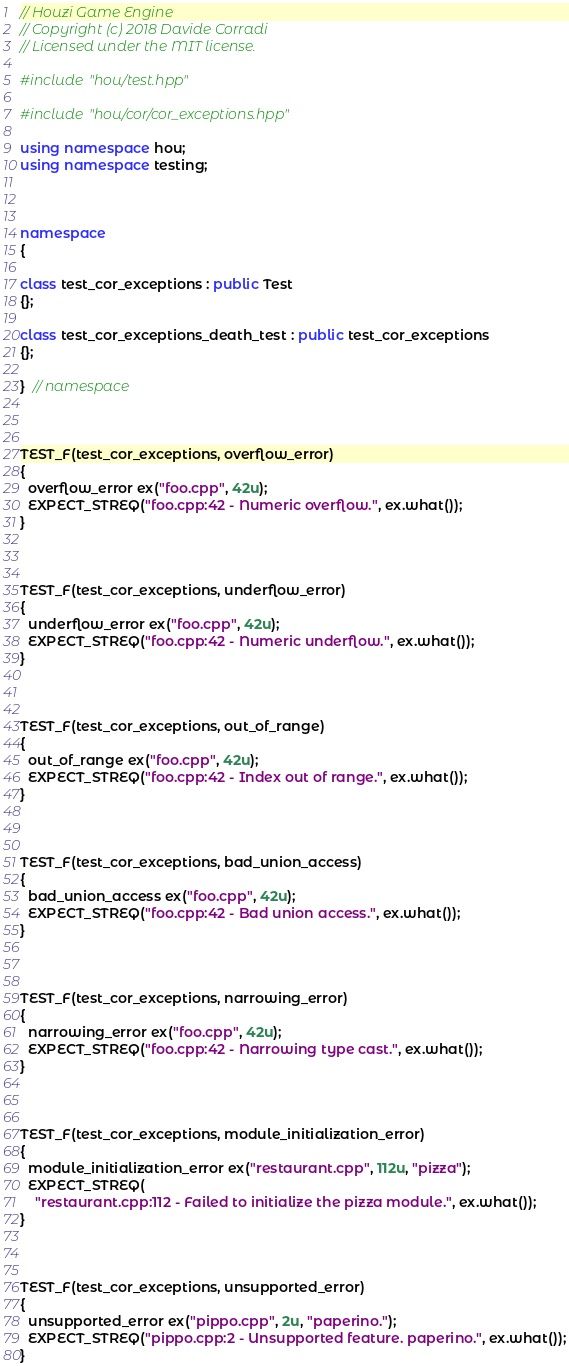<code> <loc_0><loc_0><loc_500><loc_500><_C++_>// Houzi Game Engine
// Copyright (c) 2018 Davide Corradi
// Licensed under the MIT license.

#include "hou/test.hpp"

#include "hou/cor/cor_exceptions.hpp"

using namespace hou;
using namespace testing;



namespace
{

class test_cor_exceptions : public Test
{};

class test_cor_exceptions_death_test : public test_cor_exceptions
{};

}  // namespace



TEST_F(test_cor_exceptions, overflow_error)
{
  overflow_error ex("foo.cpp", 42u);
  EXPECT_STREQ("foo.cpp:42 - Numeric overflow.", ex.what());
}



TEST_F(test_cor_exceptions, underflow_error)
{
  underflow_error ex("foo.cpp", 42u);
  EXPECT_STREQ("foo.cpp:42 - Numeric underflow.", ex.what());
}



TEST_F(test_cor_exceptions, out_of_range)
{
  out_of_range ex("foo.cpp", 42u);
  EXPECT_STREQ("foo.cpp:42 - Index out of range.", ex.what());
}



TEST_F(test_cor_exceptions, bad_union_access)
{
  bad_union_access ex("foo.cpp", 42u);
  EXPECT_STREQ("foo.cpp:42 - Bad union access.", ex.what());
}



TEST_F(test_cor_exceptions, narrowing_error)
{
  narrowing_error ex("foo.cpp", 42u);
  EXPECT_STREQ("foo.cpp:42 - Narrowing type cast.", ex.what());
}



TEST_F(test_cor_exceptions, module_initialization_error)
{
  module_initialization_error ex("restaurant.cpp", 112u, "pizza");
  EXPECT_STREQ(
    "restaurant.cpp:112 - Failed to initialize the pizza module.", ex.what());
}



TEST_F(test_cor_exceptions, unsupported_error)
{
  unsupported_error ex("pippo.cpp", 2u, "paperino.");
  EXPECT_STREQ("pippo.cpp:2 - Unsupported feature. paperino.", ex.what());
}


</code> 